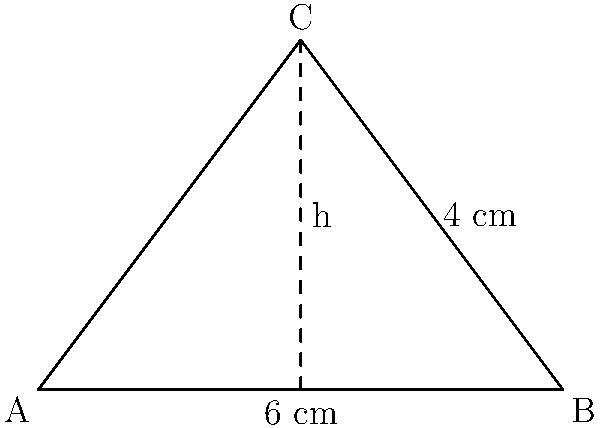You're designing a triangular call-to-action (CTA) button for a landing page. The base of the triangle is 6 cm, and its height is 4 cm. What is the area of this CTA button in square centimeters? To find the area of a triangular CTA button, we can use the formula for the area of a triangle:

$$A = \frac{1}{2} \times b \times h$$

Where:
$A$ = Area of the triangle
$b$ = Base of the triangle
$h$ = Height of the triangle

Given:
Base (b) = 6 cm
Height (h) = 4 cm

Let's substitute these values into the formula:

$$A = \frac{1}{2} \times 6 \text{ cm} \times 4 \text{ cm}$$

$$A = \frac{1}{2} \times 24 \text{ cm}^2$$

$$A = 12 \text{ cm}^2$$

Therefore, the area of the triangular CTA button is 12 square centimeters.
Answer: 12 cm² 